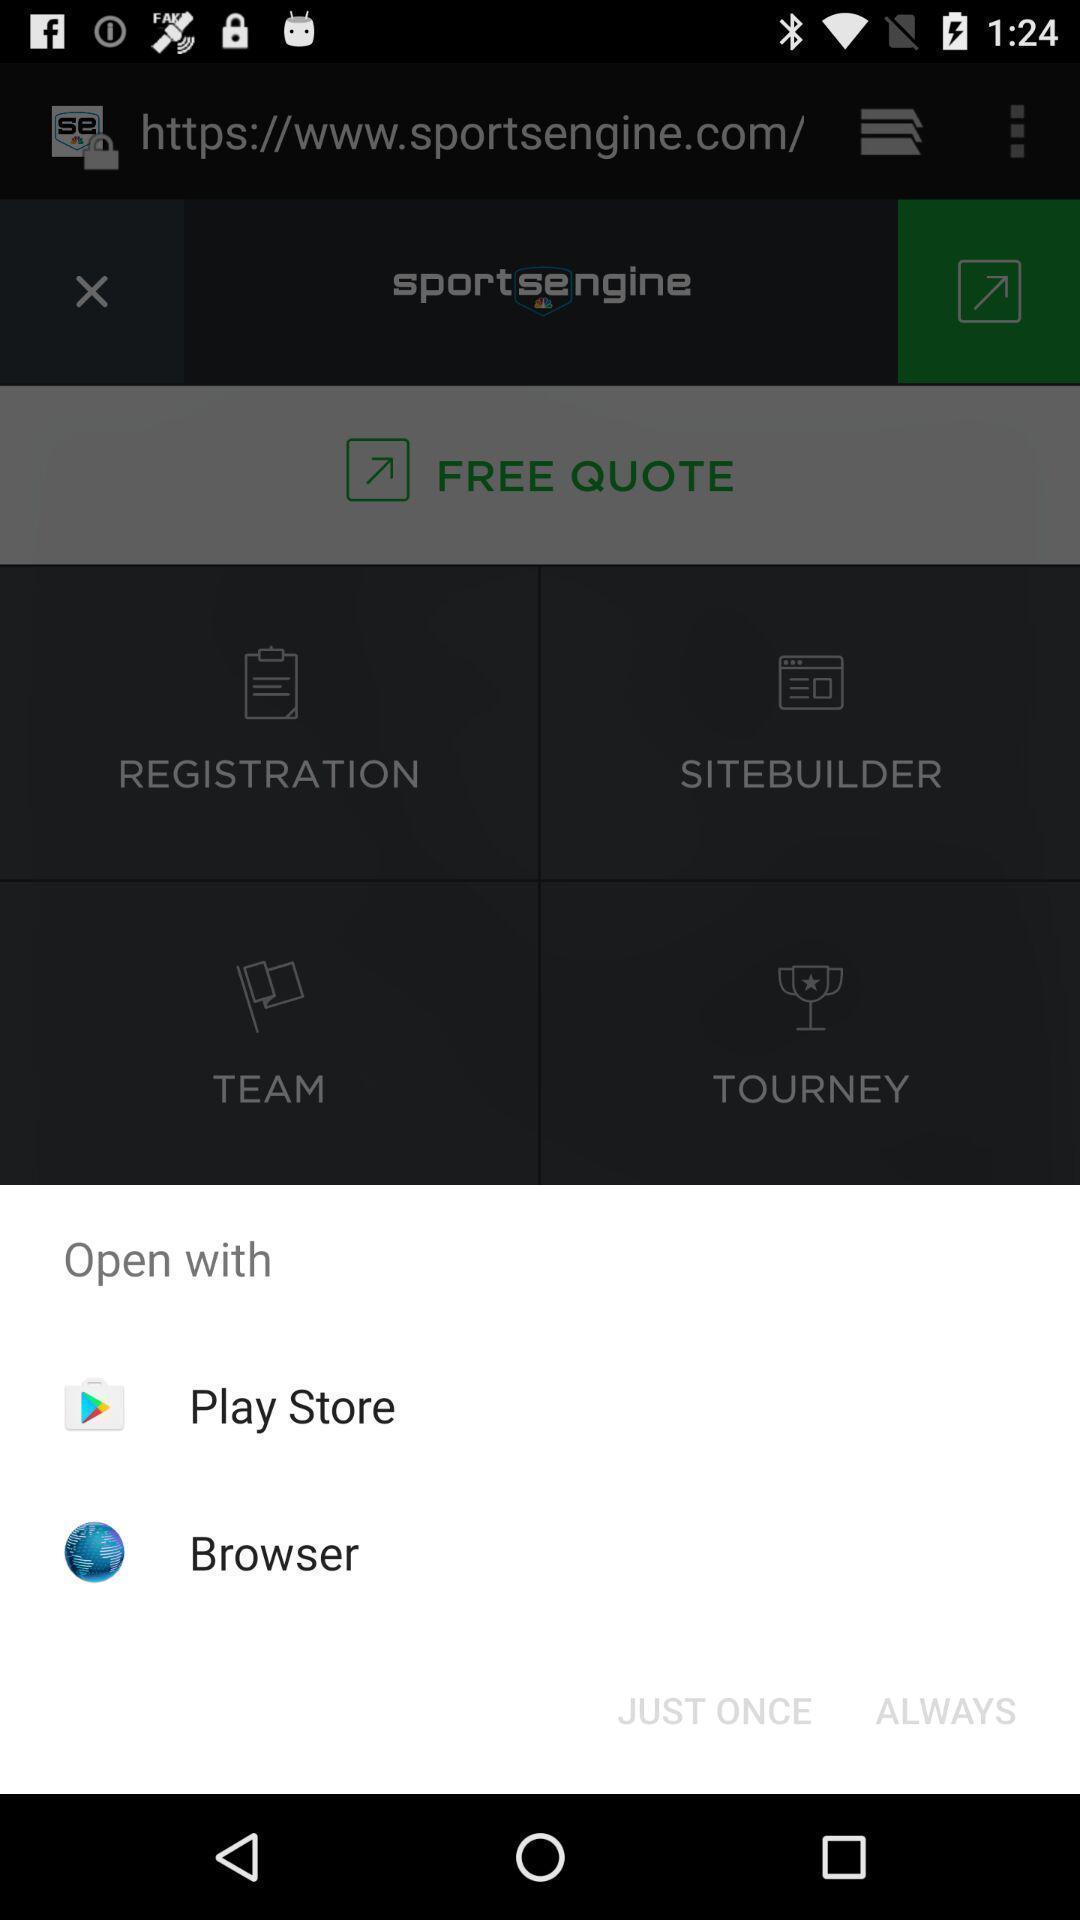Explain the elements present in this screenshot. Pop-up shows two applications with icons. 